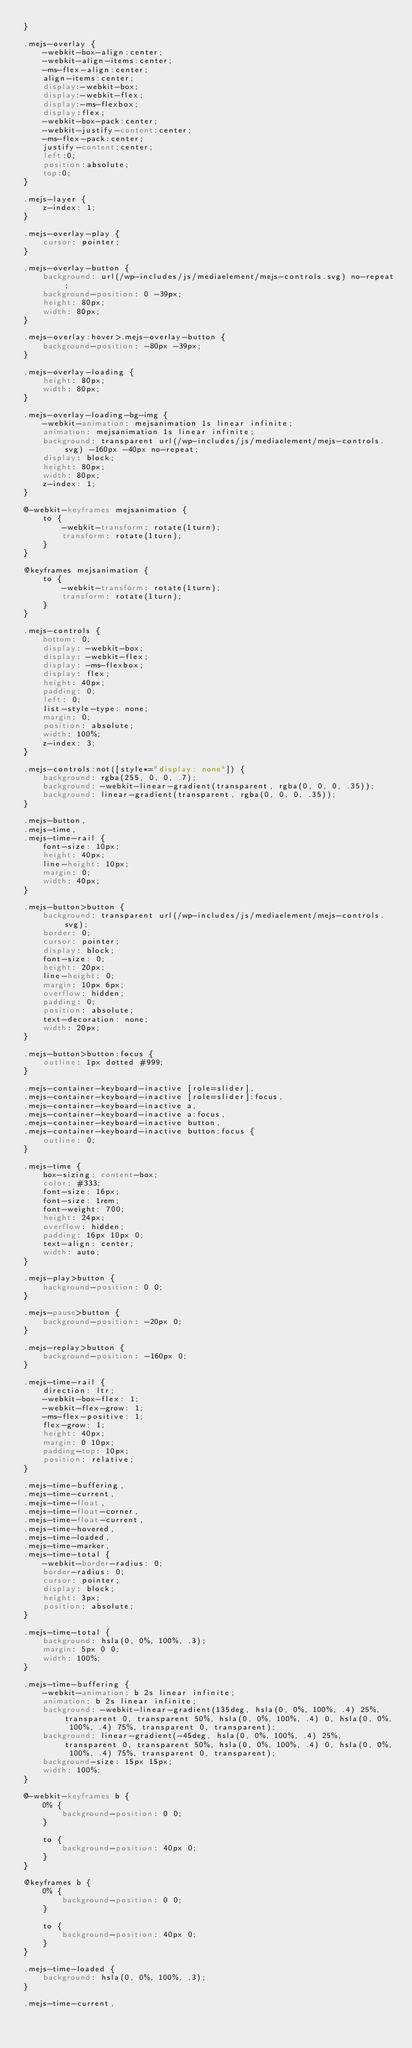<code> <loc_0><loc_0><loc_500><loc_500><_CSS_>}

.mejs-overlay {
    -webkit-box-align:center;
    -webkit-align-items:center;
    -ms-flex-align:center;
    align-items:center;
    display:-webkit-box;
    display:-webkit-flex;
    display:-ms-flexbox;
    display:flex;
    -webkit-box-pack:center;
    -webkit-justify-content:center;
    -ms-flex-pack:center;
    justify-content:center;
    left:0;
    position:absolute;
    top:0;
}

.mejs-layer {
    z-index: 1;
}

.mejs-overlay-play {
    cursor: pointer;
}

.mejs-overlay-button {
    background: url(/wp-includes/js/mediaelement/mejs-controls.svg) no-repeat;
    background-position: 0 -39px;
    height: 80px;
    width: 80px;
}

.mejs-overlay:hover>.mejs-overlay-button {
    background-position: -80px -39px;
}

.mejs-overlay-loading {
    height: 80px;
    width: 80px;
}

.mejs-overlay-loading-bg-img {
    -webkit-animation: mejsanimation 1s linear infinite;
    animation: mejsanimation 1s linear infinite;
    background: transparent url(/wp-includes/js/mediaelement/mejs-controls.svg) -160px -40px no-repeat;
    display: block;
    height: 80px;
    width: 80px;
    z-index: 1;
}

@-webkit-keyframes mejsanimation {
    to {
        -webkit-transform: rotate(1turn);
        transform: rotate(1turn);
    }
}

@keyframes mejsanimation {
    to {
        -webkit-transform: rotate(1turn);
        transform: rotate(1turn);
    }
}

.mejs-controls {
    bottom: 0;
    display: -webkit-box;
    display: -webkit-flex;
    display: -ms-flexbox;
    display: flex;
    height: 40px;
    padding: 0;
    left: 0;
    list-style-type: none;
    margin: 0;
    position: absolute;
    width: 100%;
    z-index: 3;
}

.mejs-controls:not([style*="display: none"]) {
    background: rgba(255, 0, 0, .7);
    background: -webkit-linear-gradient(transparent, rgba(0, 0, 0, .35));
    background: linear-gradient(transparent, rgba(0, 0, 0, .35));
}

.mejs-button,
.mejs-time,
.mejs-time-rail {
    font-size: 10px;
    height: 40px;
    line-height: 10px;
    margin: 0;
    width: 40px;
}

.mejs-button>button {
    background: transparent url(/wp-includes/js/mediaelement/mejs-controls.svg);
    border: 0;
    cursor: pointer;
    display: block;
    font-size: 0;
    height: 20px;
    line-height: 0;
    margin: 10px 6px;
    overflow: hidden;
    padding: 0;
    position: absolute;
    text-decoration: none;
    width: 20px;
}

.mejs-button>button:focus {
    outline: 1px dotted #999;
}

.mejs-container-keyboard-inactive [role=slider],
.mejs-container-keyboard-inactive [role=slider]:focus,
.mejs-container-keyboard-inactive a,
.mejs-container-keyboard-inactive a:focus,
.mejs-container-keyboard-inactive button,
.mejs-container-keyboard-inactive button:focus {
    outline: 0;
}

.mejs-time {
    box-sizing: content-box;
    color: #333;
    font-size: 16px;
    font-size: 1rem;
    font-weight: 700;
    height: 24px;
    overflow: hidden;
    padding: 16px 10px 0;
    text-align: center;
    width: auto;
}

.mejs-play>button {
    background-position: 0 0;
}

.mejs-pause>button {
    background-position: -20px 0;
}

.mejs-replay>button {
    background-position: -160px 0;
}

.mejs-time-rail {
    direction: ltr;
    -webkit-box-flex: 1;
    -webkit-flex-grow: 1;
    -ms-flex-positive: 1;
    flex-grow: 1;
    height: 40px;
    margin: 0 10px;
    padding-top: 10px;
    position: relative;
}

.mejs-time-buffering,
.mejs-time-current,
.mejs-time-float,
.mejs-time-float-corner,
.mejs-time-float-current,
.mejs-time-hovered,
.mejs-time-loaded,
.mejs-time-marker,
.mejs-time-total {
    -webkit-border-radius: 0;
    border-radius: 0;
    cursor: pointer;
    display: block;
    height: 3px;
    position: absolute;
}

.mejs-time-total {
    background: hsla(0, 0%, 100%, .3);
    margin: 5px 0 0;
    width: 100%;
}

.mejs-time-buffering {
    -webkit-animation: b 2s linear infinite;
    animation: b 2s linear infinite;
    background: -webkit-linear-gradient(135deg, hsla(0, 0%, 100%, .4) 25%, transparent 0, transparent 50%, hsla(0, 0%, 100%, .4) 0, hsla(0, 0%, 100%, .4) 75%, transparent 0, transparent);
    background: linear-gradient(-45deg, hsla(0, 0%, 100%, .4) 25%, transparent 0, transparent 50%, hsla(0, 0%, 100%, .4) 0, hsla(0, 0%, 100%, .4) 75%, transparent 0, transparent);
    background-size: 15px 15px;
    width: 100%;
}

@-webkit-keyframes b {
    0% {
        background-position: 0 0;
    }

    to {
        background-position: 40px 0;
    }
}

@keyframes b {
    0% {
        background-position: 0 0;
    }

    to {
        background-position: 40px 0;
    }
}

.mejs-time-loaded {
    background: hsla(0, 0%, 100%, .3);
}

.mejs-time-current,</code> 